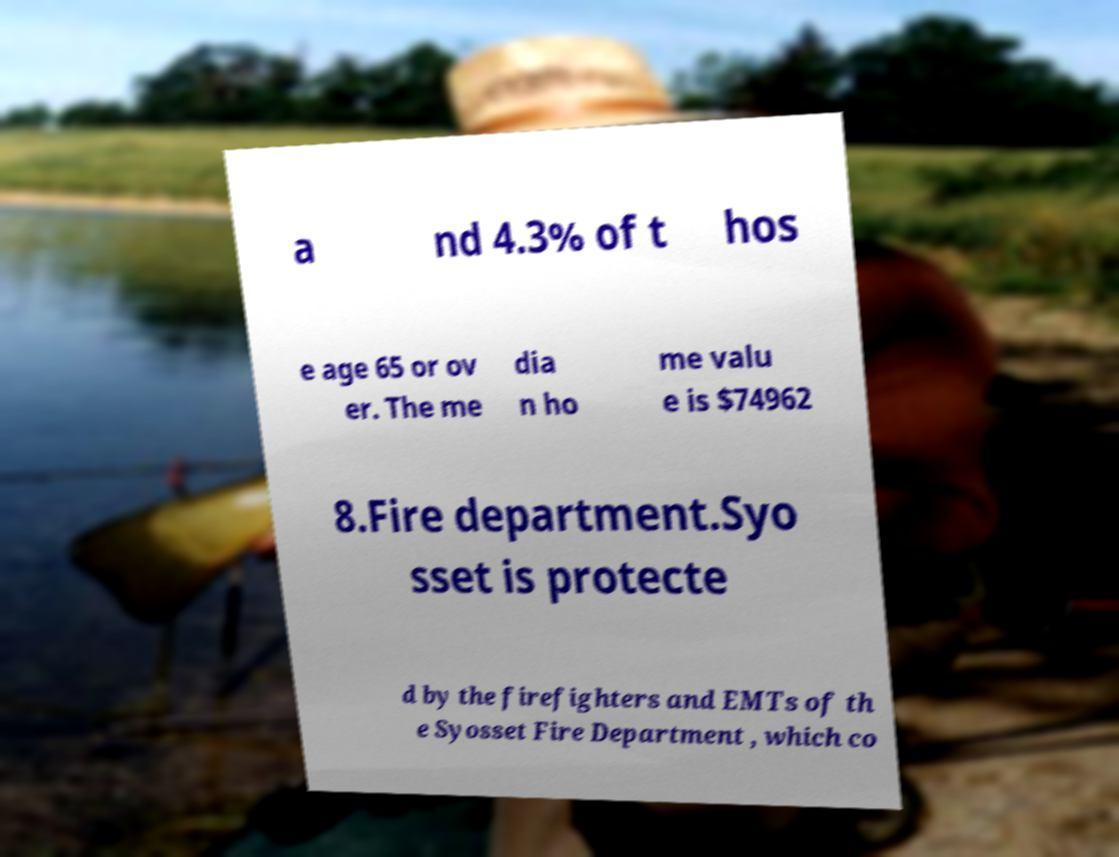Please identify and transcribe the text found in this image. a nd 4.3% of t hos e age 65 or ov er. The me dia n ho me valu e is $74962 8.Fire department.Syo sset is protecte d by the firefighters and EMTs of th e Syosset Fire Department , which co 